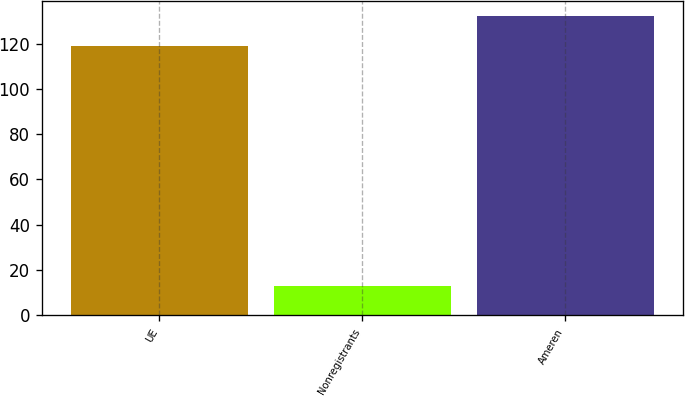<chart> <loc_0><loc_0><loc_500><loc_500><bar_chart><fcel>UE<fcel>Nonregistrants<fcel>Ameren<nl><fcel>119<fcel>13<fcel>132<nl></chart> 